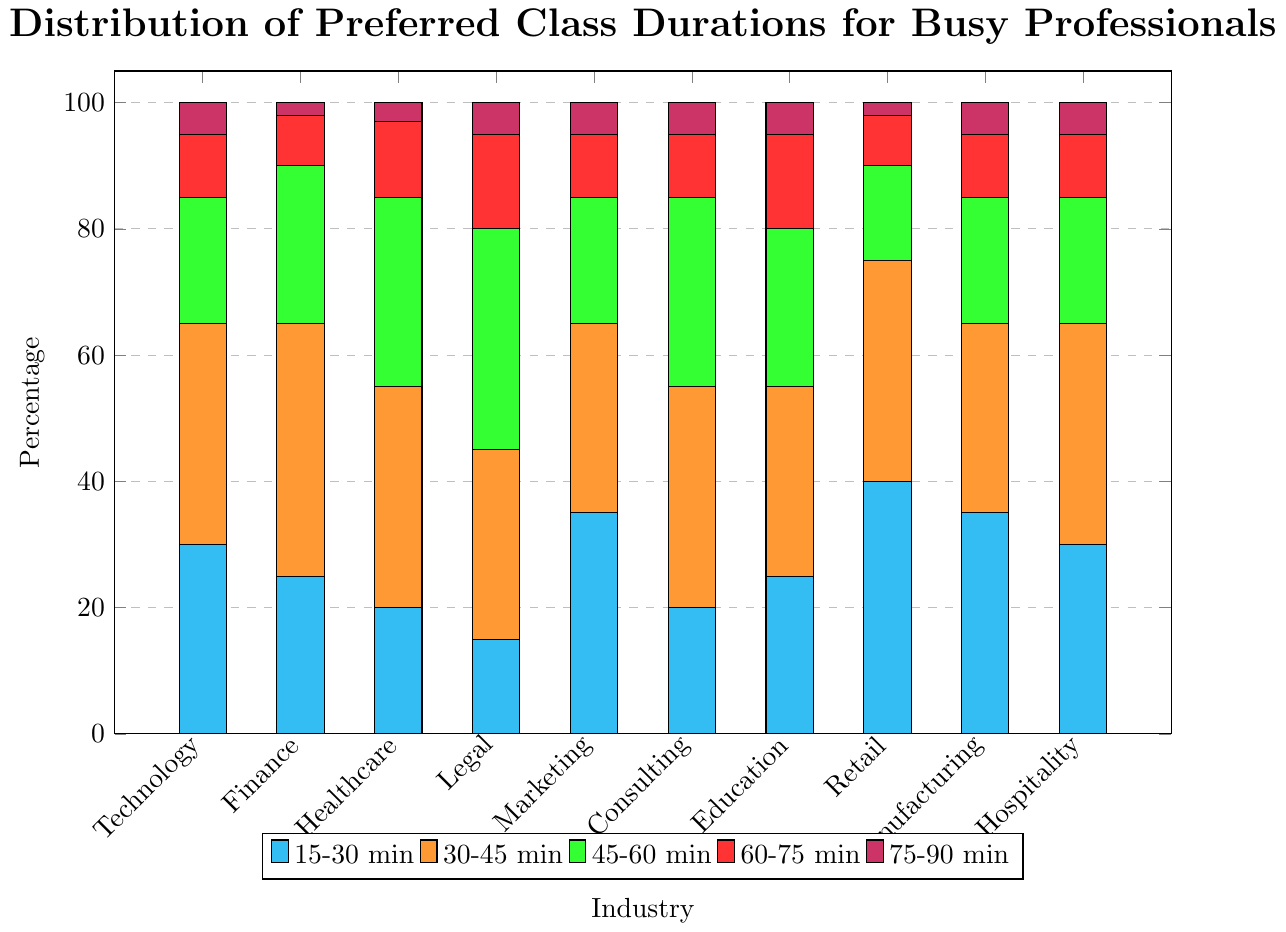What is the most preferred class duration in the technology industry? To determine the most preferred class duration in the technology industry, compare the heights of the bars corresponding to each duration (15-30 min, 30-45 min, etc.). The highest bar represents the most preferred duration, which is the 30-45 min.
Answer: 30-45 min Which industry has the highest preference for 15-30 minute classes? Examine the heights of the bars for 15-30 minute classes (cyan) across all industries. The highest bar is found in the retail industry.
Answer: Retail What is the least preferred class duration in the finance industry? Identify the shortest bar for the finance industry by comparing the heights of bars for each duration. The shortest bar corresponds to the 75-90 min duration.
Answer: 75-90 min Across all industries, which class duration is generally least preferred? Summarize the general trend by identifying the smallest group of bars (visually smaller) across all industries. The smallest group of bars belongs to the 75-90 minute duration (purple).
Answer: 75-90 min How many industries have 30-45 minutes as their most preferred class duration? Count the number of industries where the highest bar corresponds to the 30-45 min duration (orange). This includes Technology, Finance, Healthcare, Consulting, Manufacturing, and Hospitality.
Answer: 6 In the healthcare industry, what is the total percentage preference for classes 45 minutes or longer? Sum the heights of the bars representing 45-60 min, 60-75 min, and 75-90 min for the healthcare industry (30 + 12 + 3).
Answer: 45% Which class duration shows the second highest preference in the legal industry? First, identify the highest bar for the legal industry, which is 45-60 min (green). The second highest bar is for the 60-75 min (red) duration.
Answer: 60-75 min Compare the preference for 15-30 minute classes in the marketing and hospitality industries. Which industry shows a higher preference? Look at the height of the cyan bars for both marketing and hospitality industries. The marketing industry has a higher bar compared to hospitality.
Answer: Marketing What is the overall trend in class duration preferences across industries? Observe the patterns in bar heights across all industries. Shorter durations (15-30 min, 30-45 min) generally have higher preferences, while longer durations (75-90 min) show much lower preferences.
Answer: Shorter durations preferred 